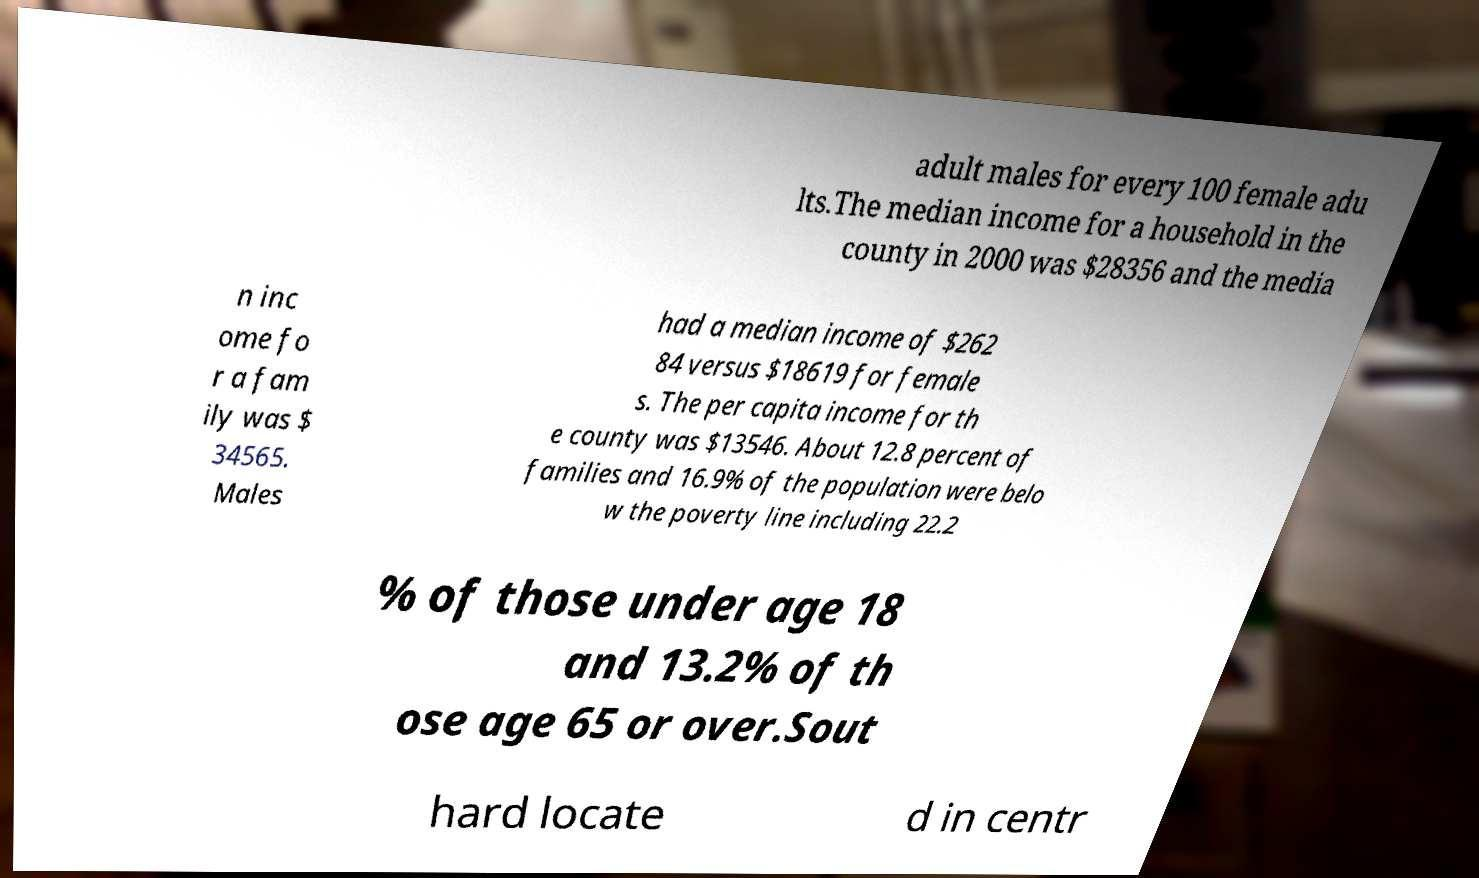I need the written content from this picture converted into text. Can you do that? adult males for every 100 female adu lts.The median income for a household in the county in 2000 was $28356 and the media n inc ome fo r a fam ily was $ 34565. Males had a median income of $262 84 versus $18619 for female s. The per capita income for th e county was $13546. About 12.8 percent of families and 16.9% of the population were belo w the poverty line including 22.2 % of those under age 18 and 13.2% of th ose age 65 or over.Sout hard locate d in centr 